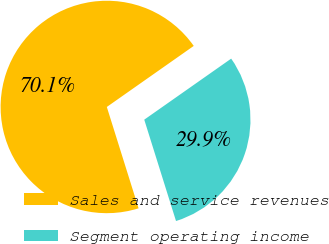Convert chart. <chart><loc_0><loc_0><loc_500><loc_500><pie_chart><fcel>Sales and service revenues<fcel>Segment operating income<nl><fcel>70.09%<fcel>29.91%<nl></chart> 